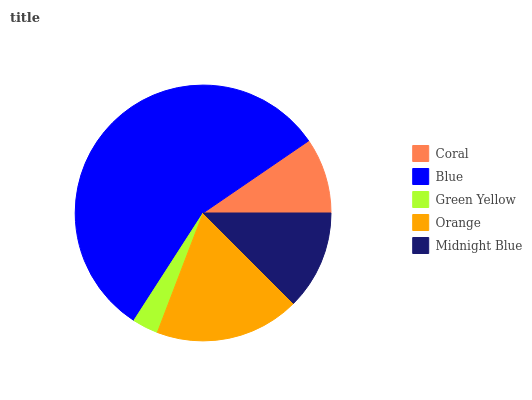Is Green Yellow the minimum?
Answer yes or no. Yes. Is Blue the maximum?
Answer yes or no. Yes. Is Blue the minimum?
Answer yes or no. No. Is Green Yellow the maximum?
Answer yes or no. No. Is Blue greater than Green Yellow?
Answer yes or no. Yes. Is Green Yellow less than Blue?
Answer yes or no. Yes. Is Green Yellow greater than Blue?
Answer yes or no. No. Is Blue less than Green Yellow?
Answer yes or no. No. Is Midnight Blue the high median?
Answer yes or no. Yes. Is Midnight Blue the low median?
Answer yes or no. Yes. Is Coral the high median?
Answer yes or no. No. Is Blue the low median?
Answer yes or no. No. 